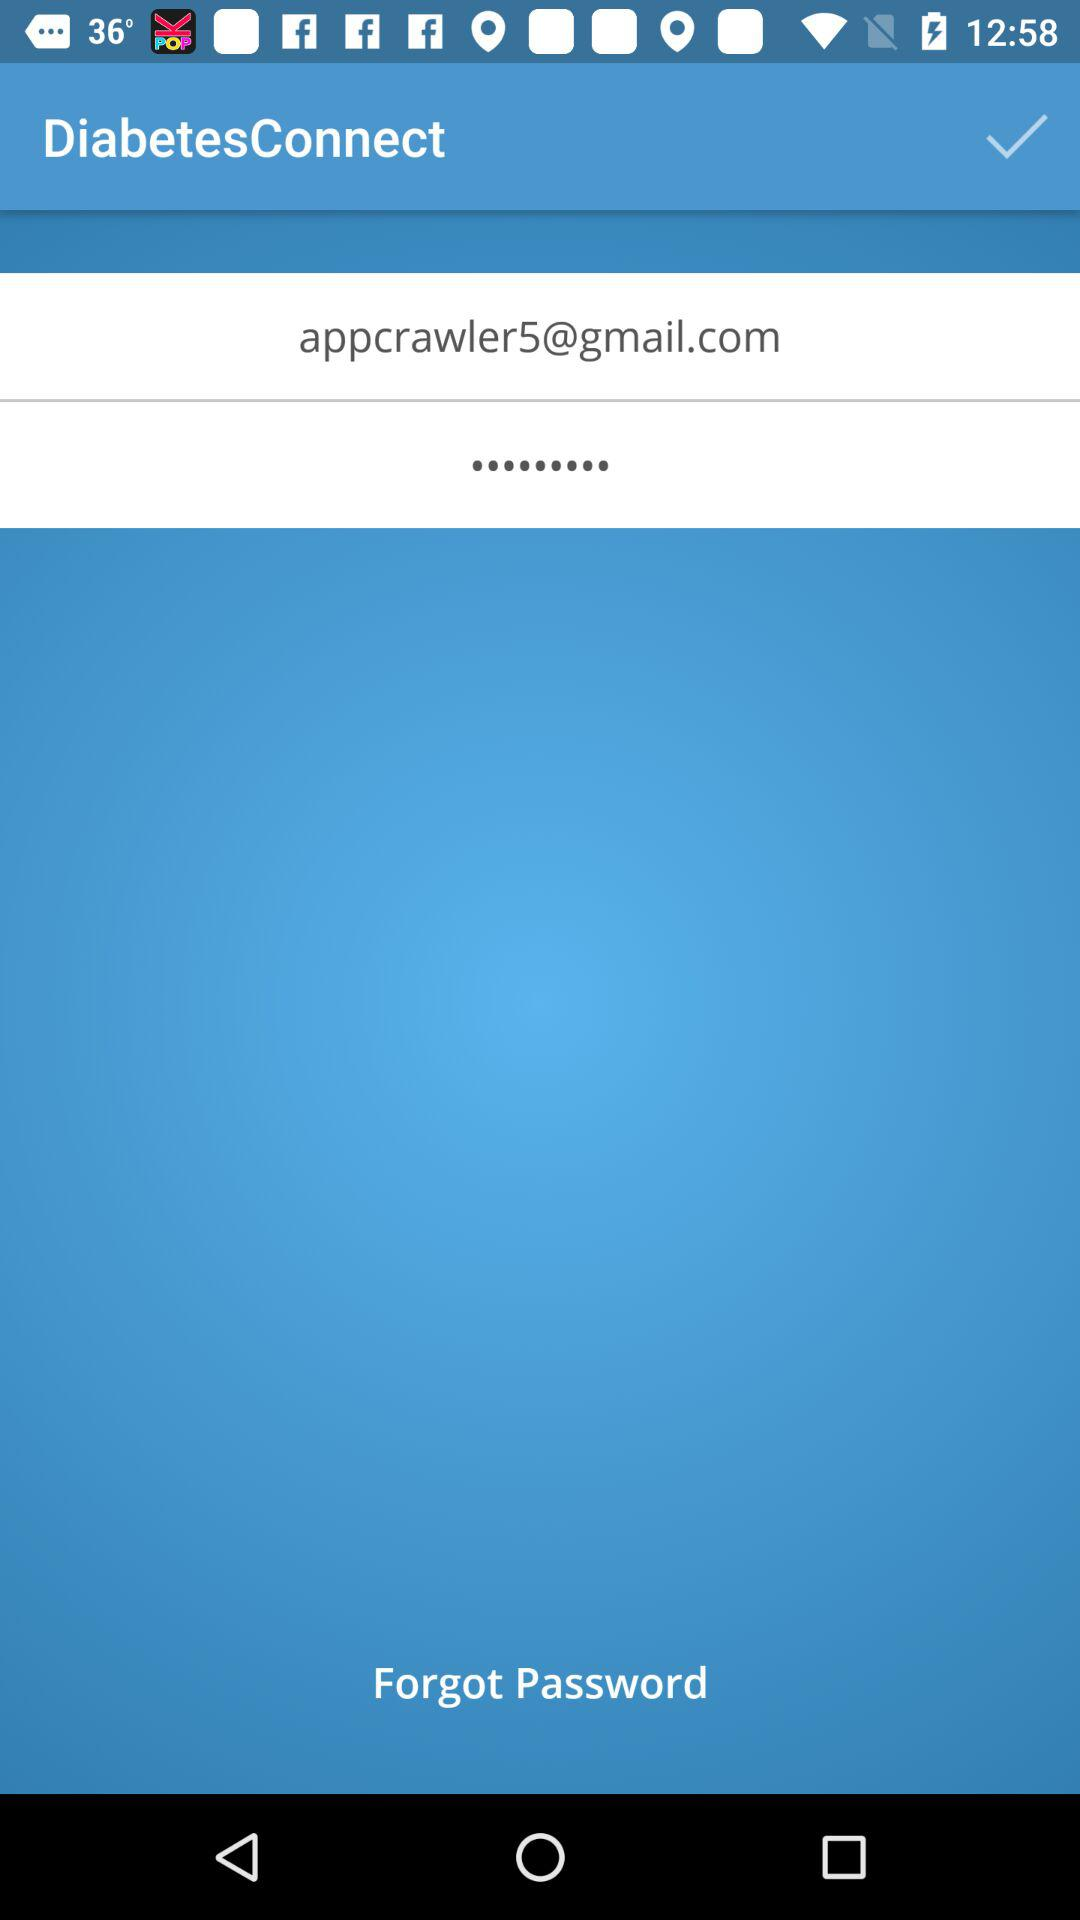What's the application name? The application name is "DiabetesConnect". 